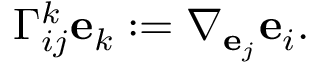<formula> <loc_0><loc_0><loc_500><loc_500>\Gamma _ { i j } ^ { k } e _ { k } \colon = \nabla _ { e _ { j } } e _ { i } .</formula> 